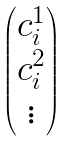<formula> <loc_0><loc_0><loc_500><loc_500>\begin{pmatrix} c _ { i } ^ { 1 } \\ c _ { i } ^ { 2 } \\ \vdots \end{pmatrix}</formula> 